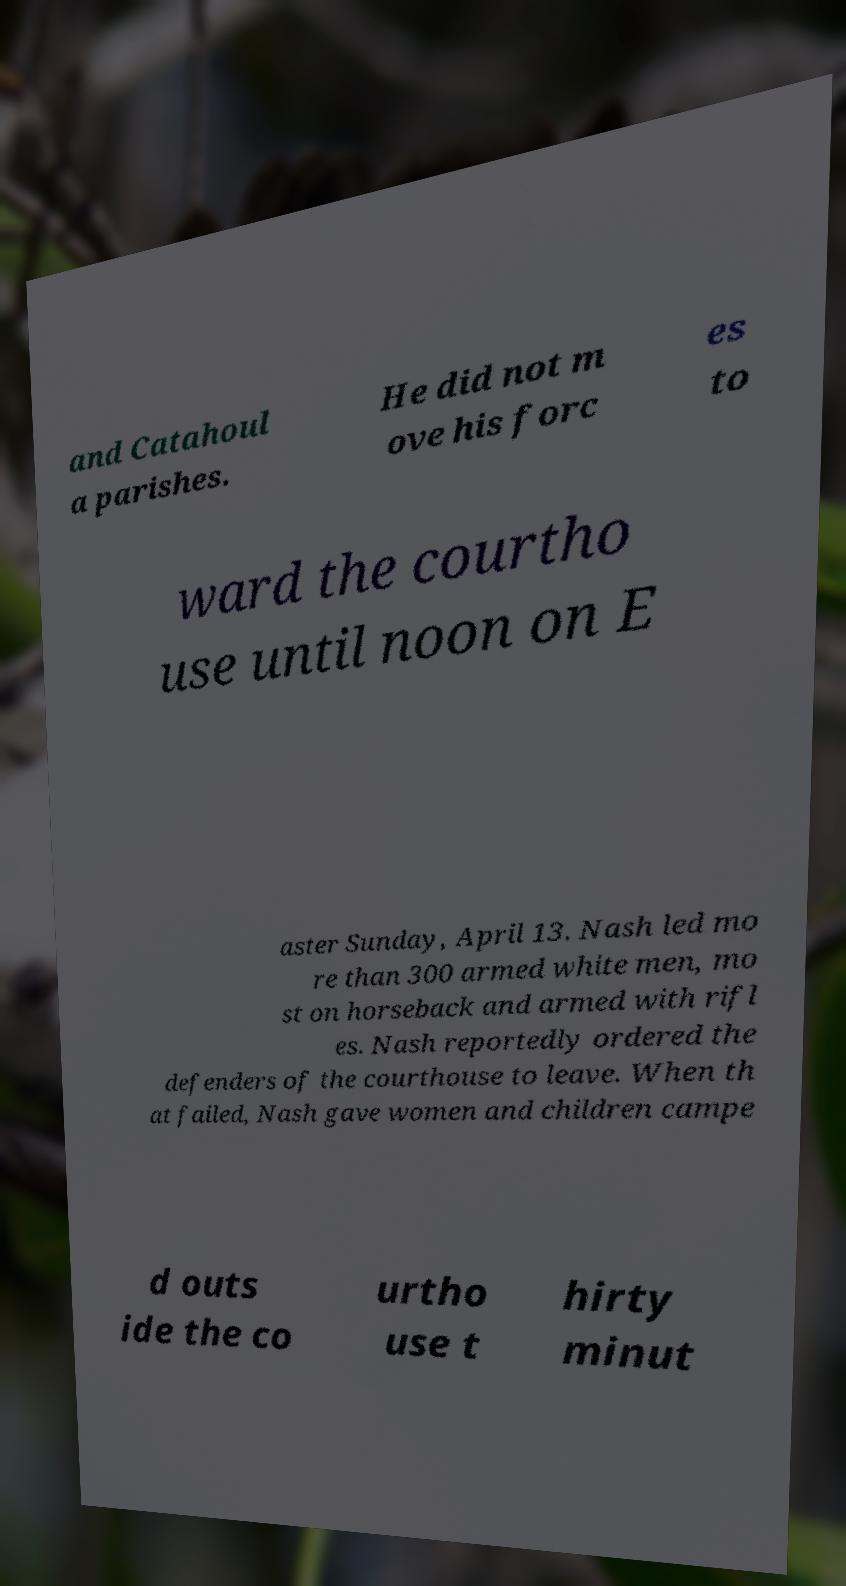I need the written content from this picture converted into text. Can you do that? and Catahoul a parishes. He did not m ove his forc es to ward the courtho use until noon on E aster Sunday, April 13. Nash led mo re than 300 armed white men, mo st on horseback and armed with rifl es. Nash reportedly ordered the defenders of the courthouse to leave. When th at failed, Nash gave women and children campe d outs ide the co urtho use t hirty minut 